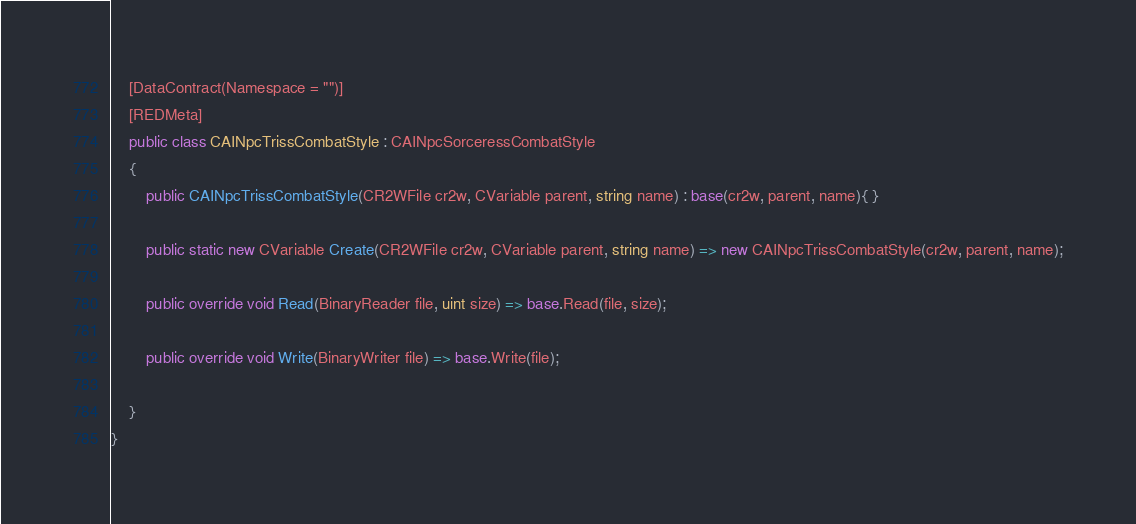Convert code to text. <code><loc_0><loc_0><loc_500><loc_500><_C#_>	[DataContract(Namespace = "")]
	[REDMeta]
	public class CAINpcTrissCombatStyle : CAINpcSorceressCombatStyle
	{
		public CAINpcTrissCombatStyle(CR2WFile cr2w, CVariable parent, string name) : base(cr2w, parent, name){ }

		public static new CVariable Create(CR2WFile cr2w, CVariable parent, string name) => new CAINpcTrissCombatStyle(cr2w, parent, name);

		public override void Read(BinaryReader file, uint size) => base.Read(file, size);

		public override void Write(BinaryWriter file) => base.Write(file);

	}
}</code> 